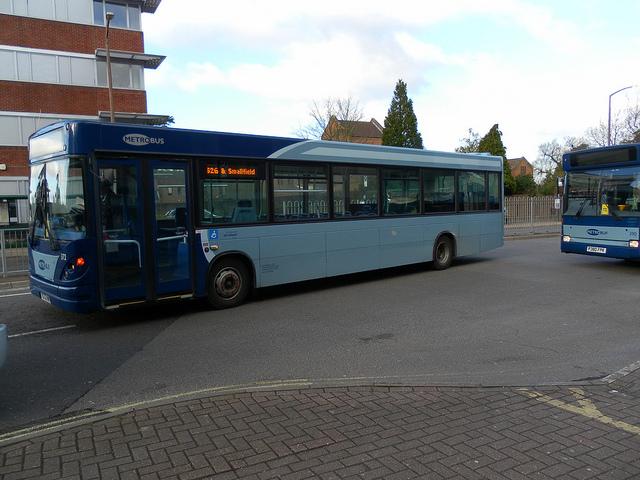Are there any people on the bus?
Short answer required. No. IS this a double Decker bus?
Keep it brief. No. What company owns these buses?
Write a very short answer. Metrobus. Is the bus green?
Answer briefly. No. Is there advertising on the bus?
Be succinct. No. Are there people in this picture?
Answer briefly. No. How many doors does the bus have?
Write a very short answer. 2. How many trash container are there?
Be succinct. 0. How many buses are there?
Concise answer only. 2. Should you tip the driver of this vehicle?
Keep it brief. No. How many bikes?
Quick response, please. 0. What does this bus run on?
Short answer required. Gas. 